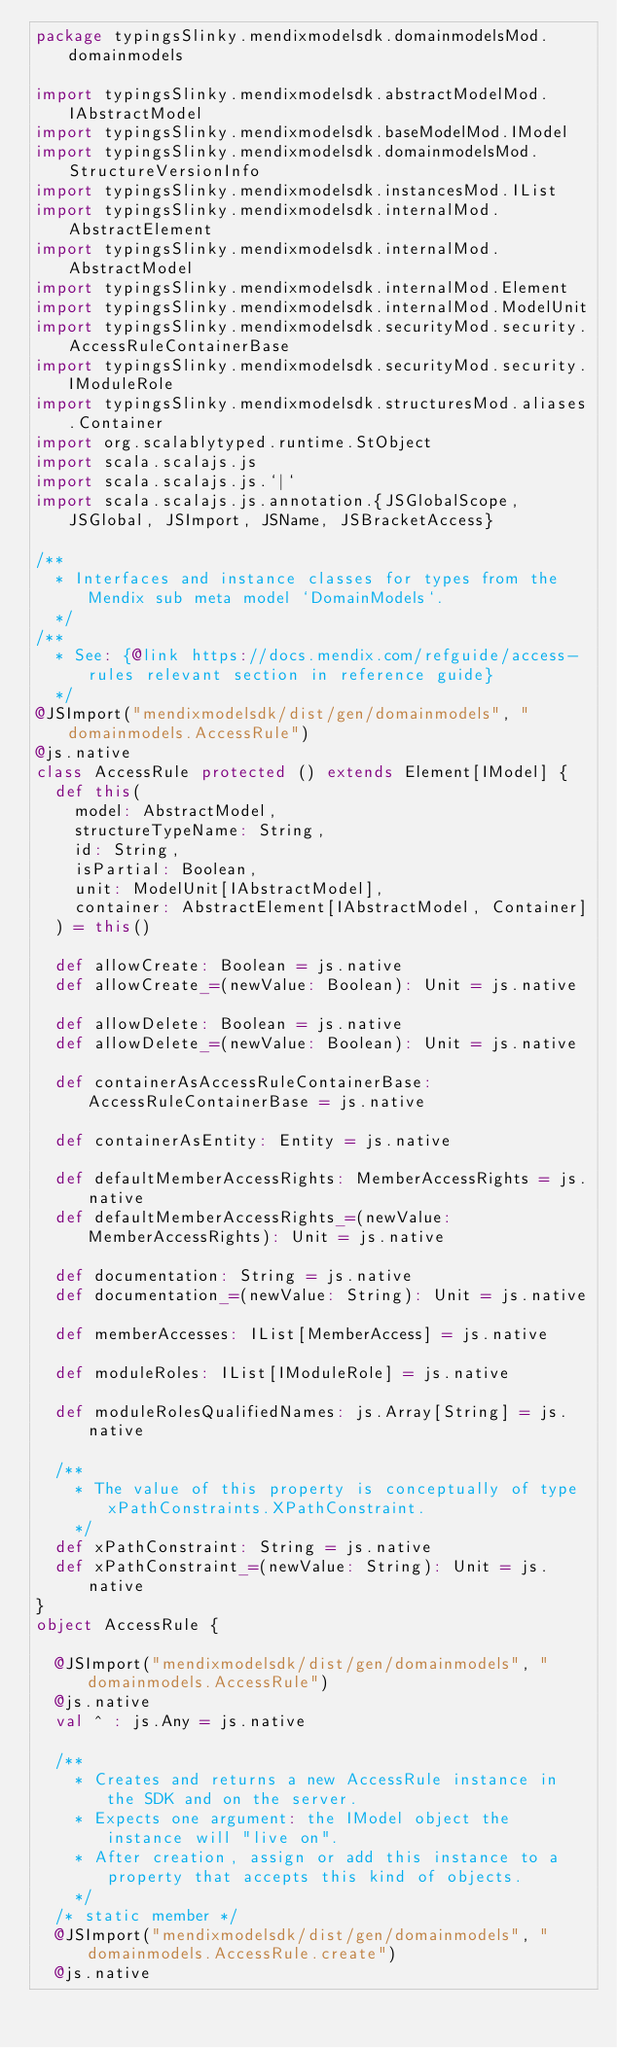<code> <loc_0><loc_0><loc_500><loc_500><_Scala_>package typingsSlinky.mendixmodelsdk.domainmodelsMod.domainmodels

import typingsSlinky.mendixmodelsdk.abstractModelMod.IAbstractModel
import typingsSlinky.mendixmodelsdk.baseModelMod.IModel
import typingsSlinky.mendixmodelsdk.domainmodelsMod.StructureVersionInfo
import typingsSlinky.mendixmodelsdk.instancesMod.IList
import typingsSlinky.mendixmodelsdk.internalMod.AbstractElement
import typingsSlinky.mendixmodelsdk.internalMod.AbstractModel
import typingsSlinky.mendixmodelsdk.internalMod.Element
import typingsSlinky.mendixmodelsdk.internalMod.ModelUnit
import typingsSlinky.mendixmodelsdk.securityMod.security.AccessRuleContainerBase
import typingsSlinky.mendixmodelsdk.securityMod.security.IModuleRole
import typingsSlinky.mendixmodelsdk.structuresMod.aliases.Container
import org.scalablytyped.runtime.StObject
import scala.scalajs.js
import scala.scalajs.js.`|`
import scala.scalajs.js.annotation.{JSGlobalScope, JSGlobal, JSImport, JSName, JSBracketAccess}

/**
  * Interfaces and instance classes for types from the Mendix sub meta model `DomainModels`.
  */
/**
  * See: {@link https://docs.mendix.com/refguide/access-rules relevant section in reference guide}
  */
@JSImport("mendixmodelsdk/dist/gen/domainmodels", "domainmodels.AccessRule")
@js.native
class AccessRule protected () extends Element[IModel] {
  def this(
    model: AbstractModel,
    structureTypeName: String,
    id: String,
    isPartial: Boolean,
    unit: ModelUnit[IAbstractModel],
    container: AbstractElement[IAbstractModel, Container]
  ) = this()
  
  def allowCreate: Boolean = js.native
  def allowCreate_=(newValue: Boolean): Unit = js.native
  
  def allowDelete: Boolean = js.native
  def allowDelete_=(newValue: Boolean): Unit = js.native
  
  def containerAsAccessRuleContainerBase: AccessRuleContainerBase = js.native
  
  def containerAsEntity: Entity = js.native
  
  def defaultMemberAccessRights: MemberAccessRights = js.native
  def defaultMemberAccessRights_=(newValue: MemberAccessRights): Unit = js.native
  
  def documentation: String = js.native
  def documentation_=(newValue: String): Unit = js.native
  
  def memberAccesses: IList[MemberAccess] = js.native
  
  def moduleRoles: IList[IModuleRole] = js.native
  
  def moduleRolesQualifiedNames: js.Array[String] = js.native
  
  /**
    * The value of this property is conceptually of type xPathConstraints.XPathConstraint.
    */
  def xPathConstraint: String = js.native
  def xPathConstraint_=(newValue: String): Unit = js.native
}
object AccessRule {
  
  @JSImport("mendixmodelsdk/dist/gen/domainmodels", "domainmodels.AccessRule")
  @js.native
  val ^ : js.Any = js.native
  
  /**
    * Creates and returns a new AccessRule instance in the SDK and on the server.
    * Expects one argument: the IModel object the instance will "live on".
    * After creation, assign or add this instance to a property that accepts this kind of objects.
    */
  /* static member */
  @JSImport("mendixmodelsdk/dist/gen/domainmodels", "domainmodels.AccessRule.create")
  @js.native</code> 